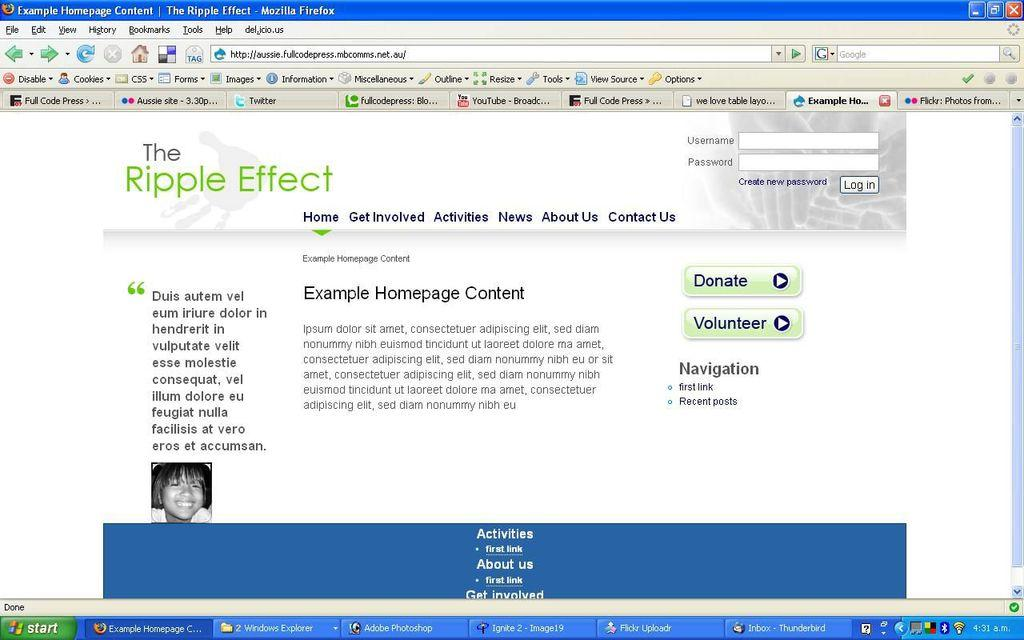<image>
Share a concise interpretation of the image provided. A windows XP screen with firefox open to example homepage content. 